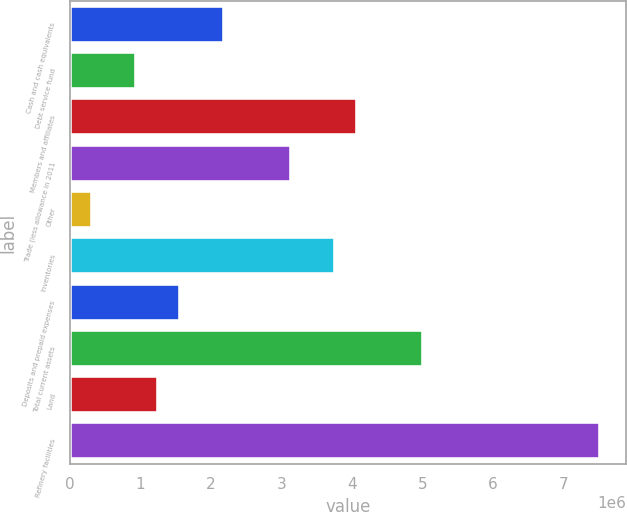<chart> <loc_0><loc_0><loc_500><loc_500><bar_chart><fcel>Cash and cash equivalents<fcel>Debt service fund<fcel>Members and affiliates<fcel>Trade (less allowance in 2011<fcel>Other<fcel>Inventories<fcel>Deposits and prepaid expenses<fcel>Total current assets<fcel>Land<fcel>Refinery facilities<nl><fcel>2.192e+06<fcel>940555<fcel>4.06918e+06<fcel>3.13059e+06<fcel>314830<fcel>3.75631e+06<fcel>1.56628e+06<fcel>5.00776e+06<fcel>1.25342e+06<fcel>7.51066e+06<nl></chart> 